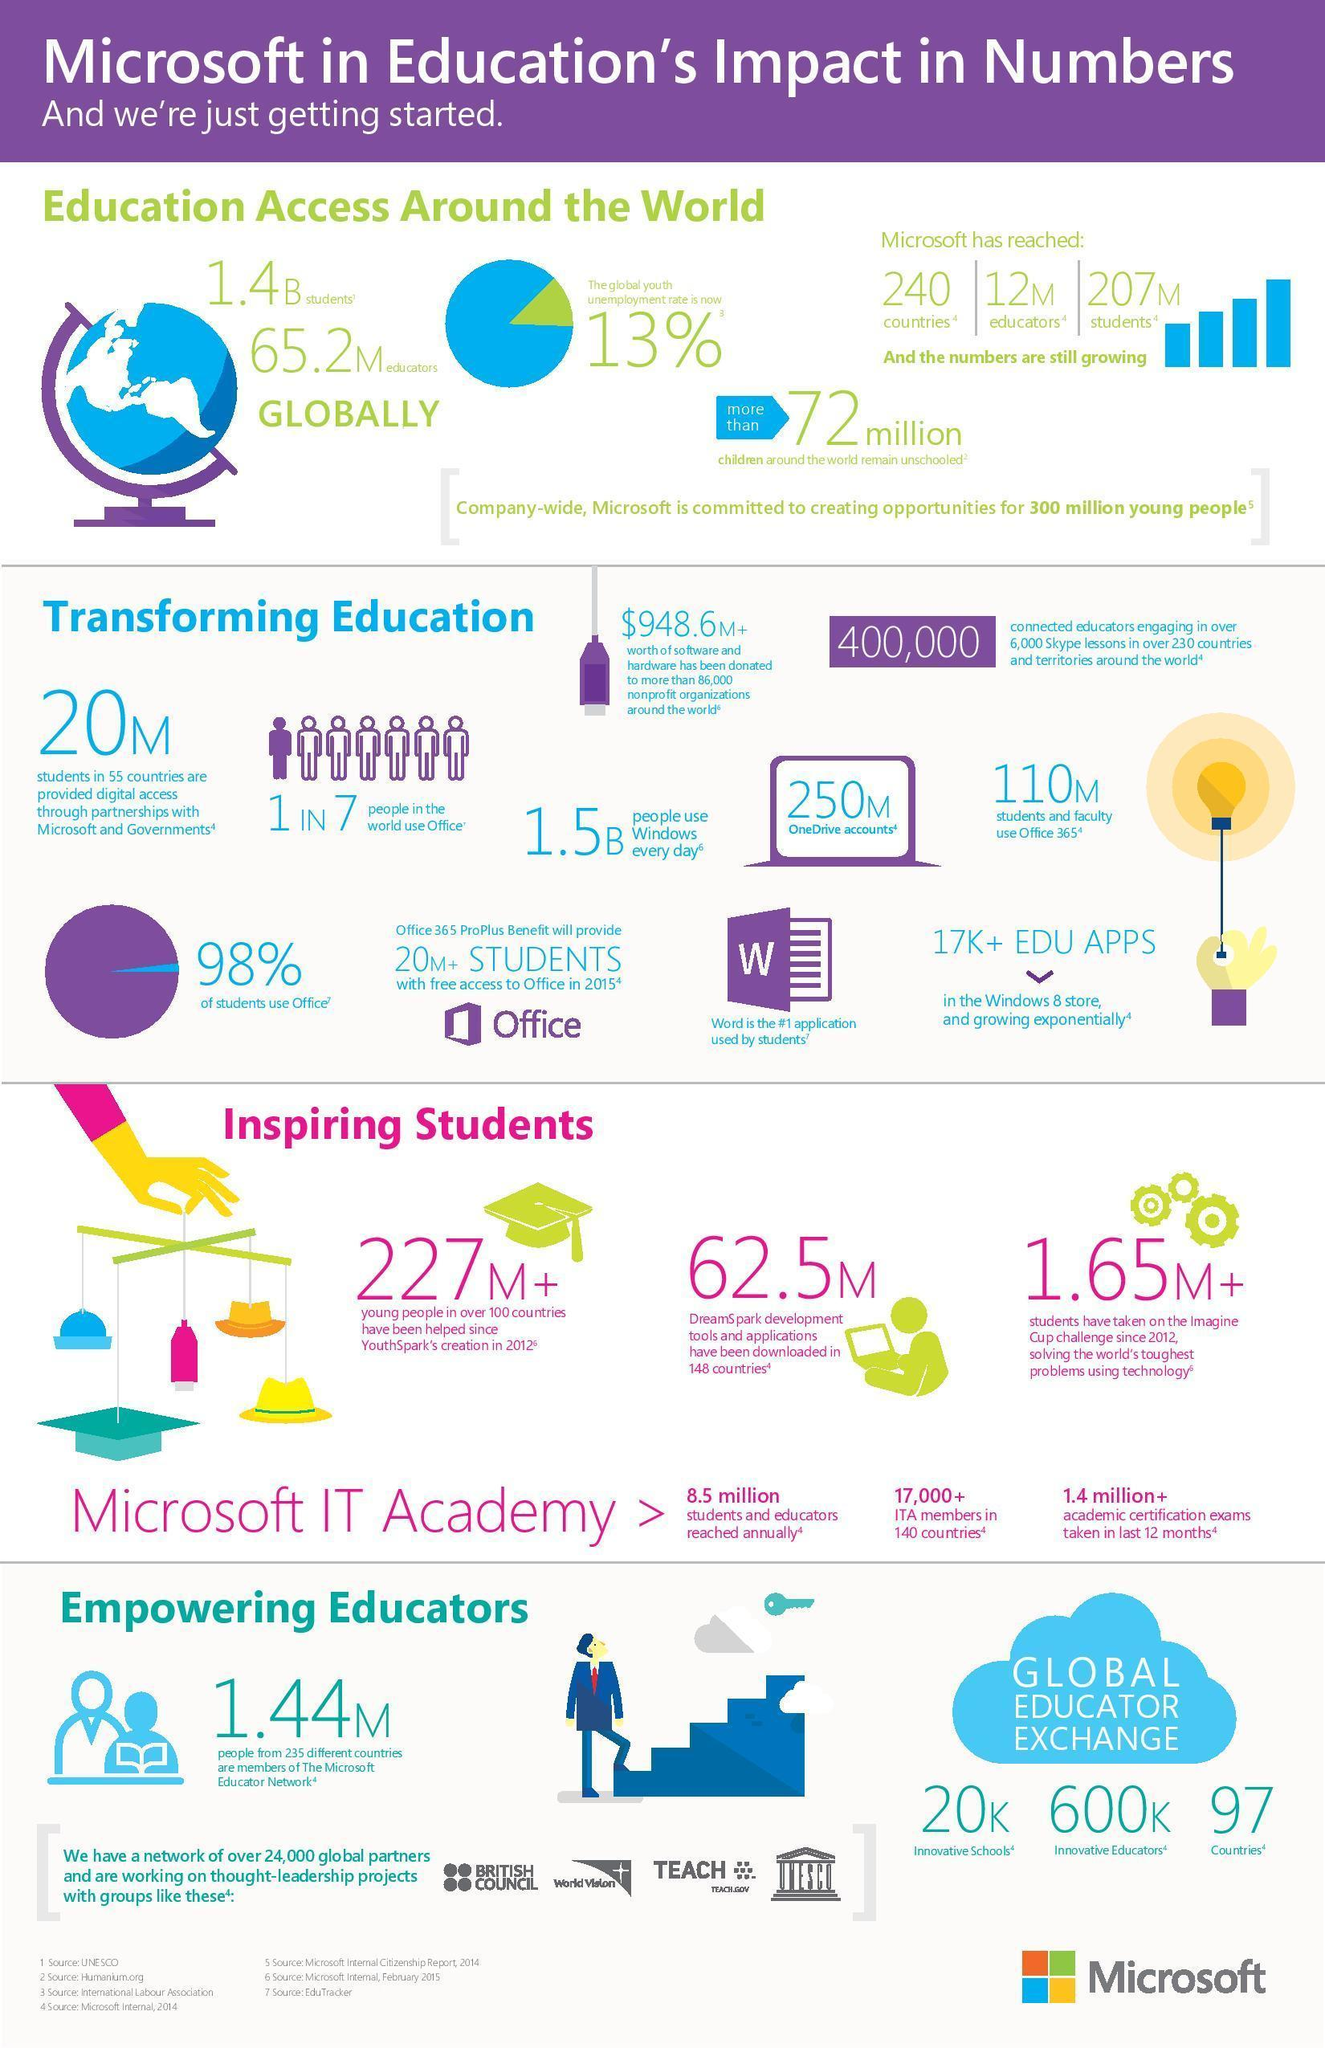What is the global youth employment rate?
Answer the question with a short phrase. 87% What percent of students do not use Office? 2% 